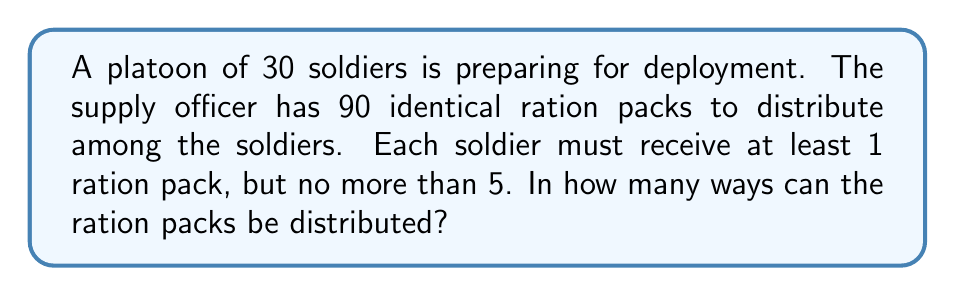Solve this math problem. Let's approach this step-by-step using the stars and bars method:

1) First, we need to distribute 30 ration packs, one to each soldier, to meet the minimum requirement. This leaves us with 60 ration packs to distribute.

2) Now, we need to find the number of ways to distribute 60 identical objects (remaining ration packs) among 30 distinct groups (soldiers), where each group can receive 0 to 4 additional objects.

3) This is equivalent to finding the number of integer solutions to the equation:

   $$x_1 + x_2 + ... + x_{30} = 60$$

   where $0 \leq x_i \leq 4$ for all $i$.

4) We can solve this using the generating function method. The generating function for each $x_i$ is:

   $$1 + z + z^2 + z^3 + z^4 = \frac{1-z^5}{1-z}$$

5) The generating function for the entire problem is:

   $$\left(\frac{1-z^5}{1-z}\right)^{30}$$

6) We need to find the coefficient of $z^{60}$ in this expansion.

7) Using the binomial theorem, we can expand this as:

   $$\sum_{k=0}^{30} \binom{30}{k}(-1)^k(1-z)^{-30+k}z^{5k}$$

8) The term we're interested in is when $60 = 5k$, i.e., $k=12$. So we need the coefficient of $z^{60}$ in:

   $$\binom{30}{12}(-1)^{12}(1-z)^{-18}z^{60}$$

9) This coefficient is:

   $$\binom{30}{12}(-1)^{12}\binom{-18+60-1}{60-1} = \binom{30}{12}\binom{77}{59}$$

10) Calculating this value gives us the final answer.
Answer: $$\binom{30}{12}\binom{77}{59} = 1,711,931,451,838,720$$ 